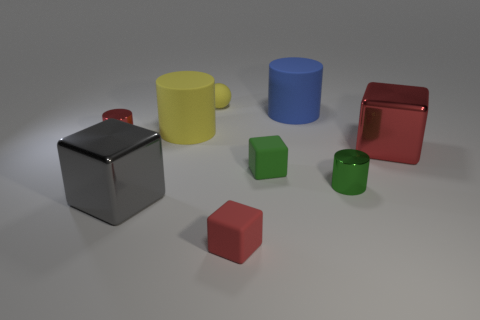The tiny rubber ball has what color?
Make the answer very short. Yellow. What number of objects are either red cylinders or blue cylinders?
Your answer should be compact. 2. Are there any other big gray objects of the same shape as the gray thing?
Offer a very short reply. No. Do the tiny object to the left of the tiny rubber sphere and the matte sphere have the same color?
Provide a succinct answer. No. There is a large metal object behind the metallic cylinder on the right side of the tiny yellow thing; what shape is it?
Keep it short and to the point. Cube. Are there any yellow cylinders that have the same size as the red metallic block?
Offer a terse response. Yes. Is the number of blue shiny cubes less than the number of small rubber blocks?
Ensure brevity in your answer.  Yes. What is the shape of the tiny red thing that is in front of the small red metallic object that is behind the large block on the left side of the tiny matte sphere?
Keep it short and to the point. Cube. How many things are either tiny metallic objects that are to the left of the tiny sphere or metallic cylinders right of the big gray cube?
Your response must be concise. 2. Are there any blue matte cylinders in front of the green matte cube?
Offer a terse response. No. 